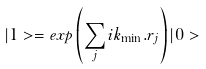<formula> <loc_0><loc_0><loc_500><loc_500>| 1 > = e x p \left ( \sum _ { j } i { k } _ { \min } . { r } _ { j } \right ) | 0 ></formula> 